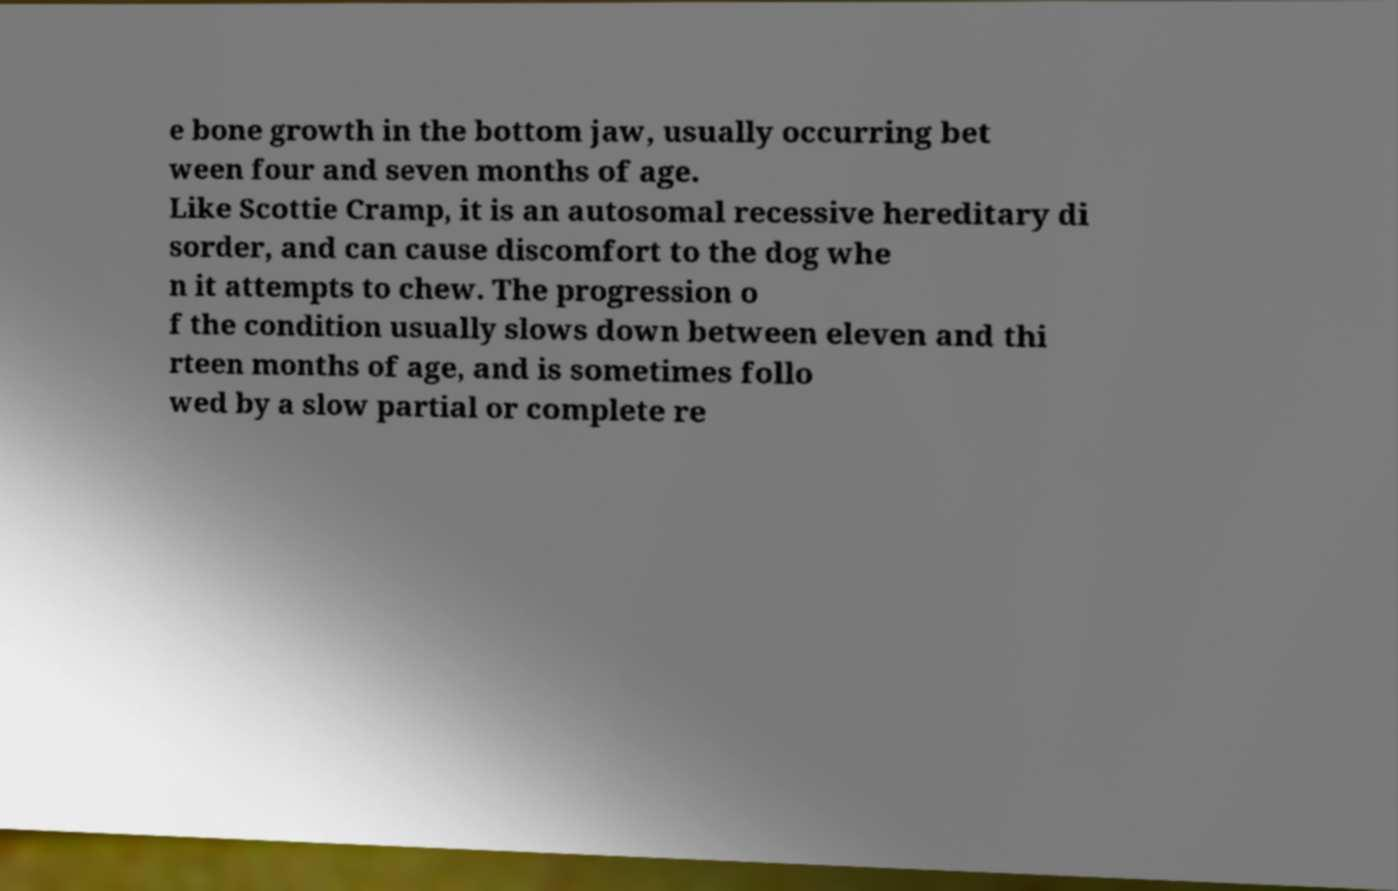Please identify and transcribe the text found in this image. e bone growth in the bottom jaw, usually occurring bet ween four and seven months of age. Like Scottie Cramp, it is an autosomal recessive hereditary di sorder, and can cause discomfort to the dog whe n it attempts to chew. The progression o f the condition usually slows down between eleven and thi rteen months of age, and is sometimes follo wed by a slow partial or complete re 